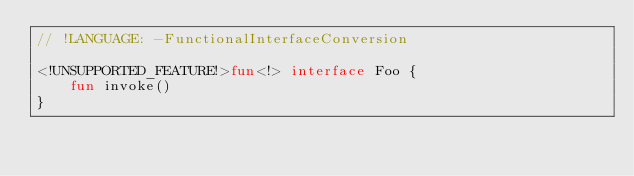<code> <loc_0><loc_0><loc_500><loc_500><_Kotlin_>// !LANGUAGE: -FunctionalInterfaceConversion

<!UNSUPPORTED_FEATURE!>fun<!> interface Foo {
    fun invoke()
}
</code> 